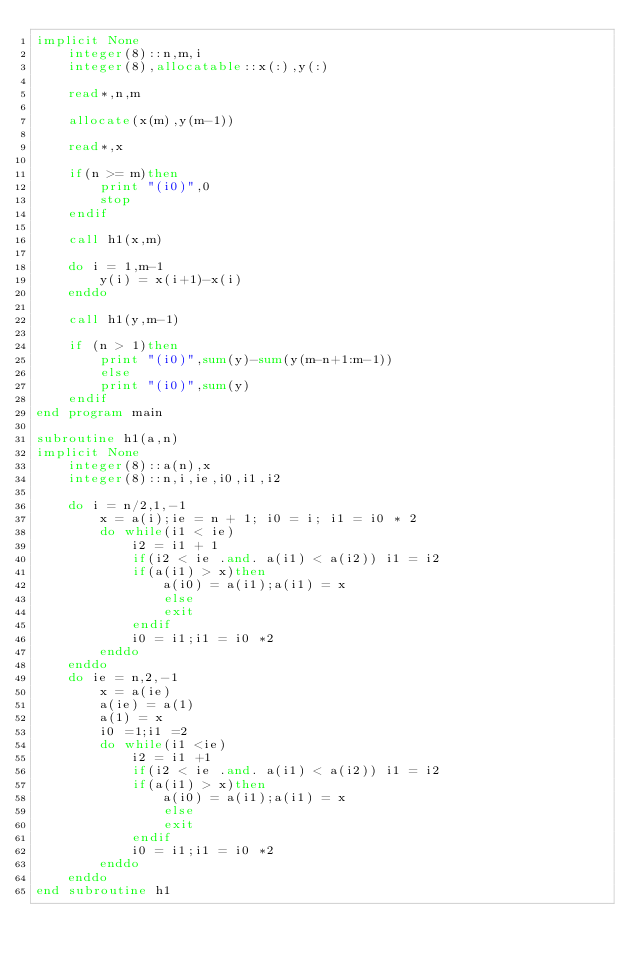Convert code to text. <code><loc_0><loc_0><loc_500><loc_500><_FORTRAN_>implicit None
	integer(8)::n,m,i
	integer(8),allocatable::x(:),y(:)
	
	read*,n,m
	
	allocate(x(m),y(m-1))
	
	read*,x
	
	if(n >= m)then
		print "(i0)",0
		stop
	endif
	
	call h1(x,m)
	
	do i = 1,m-1
		y(i) = x(i+1)-x(i)
	enddo
	
	call h1(y,m-1)
	
	if (n > 1)then
		print "(i0)",sum(y)-sum(y(m-n+1:m-1))
		else
		print "(i0)",sum(y)
	endif
end program main

subroutine h1(a,n)
implicit None
	integer(8)::a(n),x
	integer(8)::n,i,ie,i0,i1,i2
	
	do i = n/2,1,-1
		x = a(i);ie = n + 1; i0 = i; i1 = i0 * 2
		do while(i1 < ie)
			i2 = i1 + 1
			if(i2 < ie .and. a(i1) < a(i2)) i1 = i2
			if(a(i1) > x)then
				a(i0) = a(i1);a(i1) = x
				else
				exit
			endif
			i0 = i1;i1 = i0 *2
		enddo
	enddo
	do ie = n,2,-1
		x = a(ie)
		a(ie) = a(1)
		a(1) = x
		i0 =1;i1 =2
		do while(i1 <ie)
			i2 = i1 +1
			if(i2 < ie .and. a(i1) < a(i2)) i1 = i2
			if(a(i1) > x)then
				a(i0) = a(i1);a(i1) = x
				else
				exit
			endif
			i0 = i1;i1 = i0 *2
		enddo
	enddo
end subroutine h1</code> 